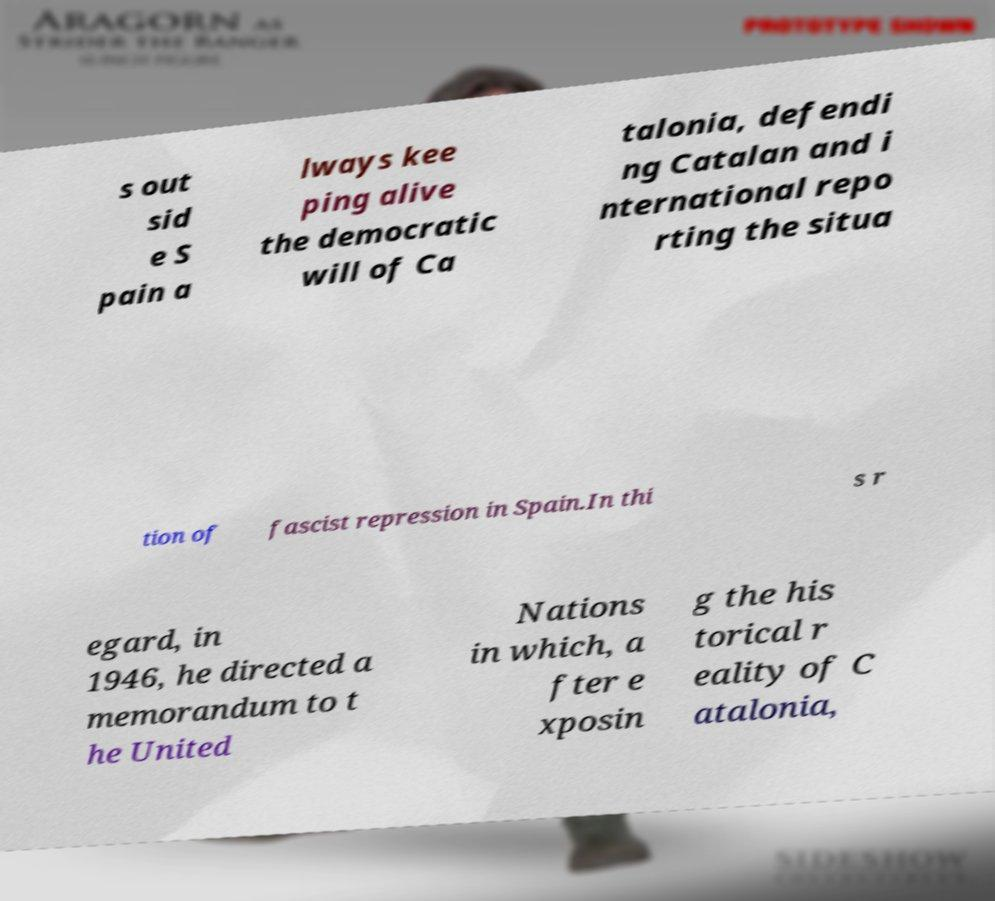There's text embedded in this image that I need extracted. Can you transcribe it verbatim? s out sid e S pain a lways kee ping alive the democratic will of Ca talonia, defendi ng Catalan and i nternational repo rting the situa tion of fascist repression in Spain.In thi s r egard, in 1946, he directed a memorandum to t he United Nations in which, a fter e xposin g the his torical r eality of C atalonia, 